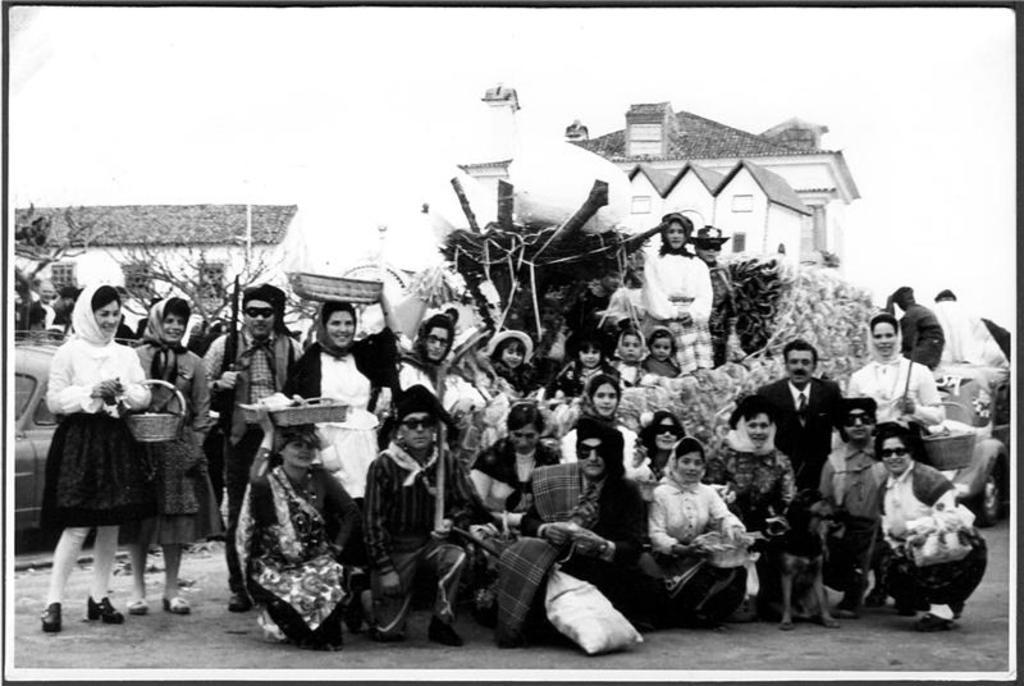What is the color scheme of the image? The image is black and white. What can be seen in the center of the image? There are many persons on the road in the center of the image. What type of natural elements are visible in the background of the image? There are trees in the background of the image. What type of man-made structures can be seen in the background of the image? There are houses in the background of the image. What type of vehicle is visible in the background of the image? There is a car in the background of the image. What is visible in the sky in the background of the image? The sky is visible in the background of the image. Where is the ornament placed in the image? There is no ornament present in the image. Can you describe the frog's behavior in the image? There is no frog present in the image. 